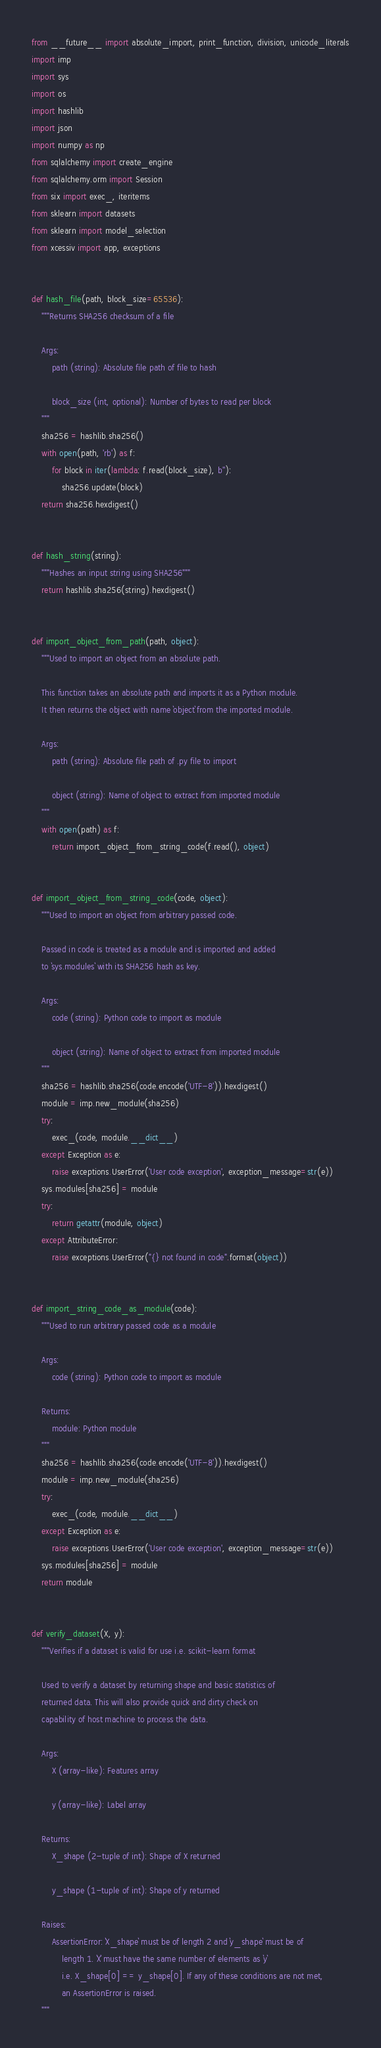Convert code to text. <code><loc_0><loc_0><loc_500><loc_500><_Python_>from __future__ import absolute_import, print_function, division, unicode_literals
import imp
import sys
import os
import hashlib
import json
import numpy as np
from sqlalchemy import create_engine
from sqlalchemy.orm import Session
from six import exec_, iteritems
from sklearn import datasets
from sklearn import model_selection
from xcessiv import app, exceptions


def hash_file(path, block_size=65536):
    """Returns SHA256 checksum of a file

    Args:
        path (string): Absolute file path of file to hash

        block_size (int, optional): Number of bytes to read per block
    """
    sha256 = hashlib.sha256()
    with open(path, 'rb') as f:
        for block in iter(lambda: f.read(block_size), b''):
            sha256.update(block)
    return sha256.hexdigest()


def hash_string(string):
    """Hashes an input string using SHA256"""
    return hashlib.sha256(string).hexdigest()


def import_object_from_path(path, object):
    """Used to import an object from an absolute path.

    This function takes an absolute path and imports it as a Python module.
    It then returns the object with name `object` from the imported module.

    Args:
        path (string): Absolute file path of .py file to import

        object (string): Name of object to extract from imported module
    """
    with open(path) as f:
        return import_object_from_string_code(f.read(), object)


def import_object_from_string_code(code, object):
    """Used to import an object from arbitrary passed code.

    Passed in code is treated as a module and is imported and added
    to `sys.modules` with its SHA256 hash as key.

    Args:
        code (string): Python code to import as module

        object (string): Name of object to extract from imported module
    """
    sha256 = hashlib.sha256(code.encode('UTF-8')).hexdigest()
    module = imp.new_module(sha256)
    try:
        exec_(code, module.__dict__)
    except Exception as e:
        raise exceptions.UserError('User code exception', exception_message=str(e))
    sys.modules[sha256] = module
    try:
        return getattr(module, object)
    except AttributeError:
        raise exceptions.UserError("{} not found in code".format(object))


def import_string_code_as_module(code):
    """Used to run arbitrary passed code as a module

    Args:
        code (string): Python code to import as module

    Returns:
        module: Python module
    """
    sha256 = hashlib.sha256(code.encode('UTF-8')).hexdigest()
    module = imp.new_module(sha256)
    try:
        exec_(code, module.__dict__)
    except Exception as e:
        raise exceptions.UserError('User code exception', exception_message=str(e))
    sys.modules[sha256] = module
    return module


def verify_dataset(X, y):
    """Verifies if a dataset is valid for use i.e. scikit-learn format

    Used to verify a dataset by returning shape and basic statistics of
    returned data. This will also provide quick and dirty check on
    capability of host machine to process the data.

    Args:
        X (array-like): Features array

        y (array-like): Label array

    Returns:
        X_shape (2-tuple of int): Shape of X returned

        y_shape (1-tuple of int): Shape of y returned

    Raises:
        AssertionError: `X_shape` must be of length 2 and `y_shape` must be of
            length 1. `X` must have the same number of elements as `y`
            i.e. X_shape[0] == y_shape[0]. If any of these conditions are not met,
            an AssertionError is raised.
    """</code> 